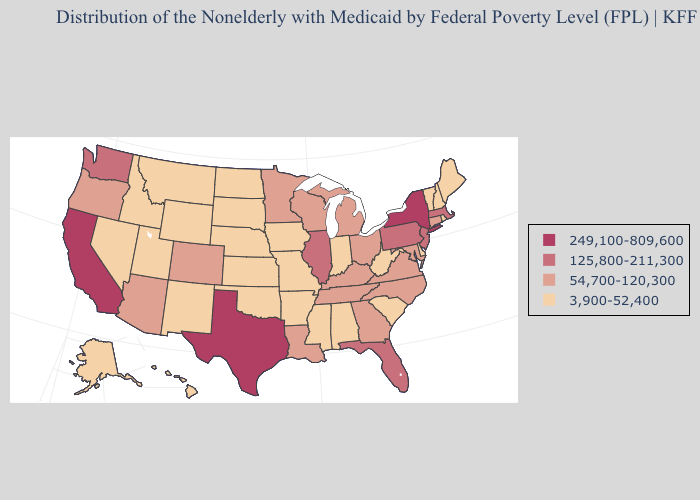Is the legend a continuous bar?
Write a very short answer. No. Name the states that have a value in the range 125,800-211,300?
Keep it brief. Florida, Illinois, Massachusetts, New Jersey, Pennsylvania, Washington. What is the value of South Dakota?
Quick response, please. 3,900-52,400. Does Kansas have a lower value than Nebraska?
Short answer required. No. What is the value of Massachusetts?
Write a very short answer. 125,800-211,300. What is the value of Washington?
Give a very brief answer. 125,800-211,300. What is the value of Utah?
Be succinct. 3,900-52,400. Among the states that border Ohio , which have the highest value?
Write a very short answer. Pennsylvania. Name the states that have a value in the range 125,800-211,300?
Give a very brief answer. Florida, Illinois, Massachusetts, New Jersey, Pennsylvania, Washington. Does the first symbol in the legend represent the smallest category?
Write a very short answer. No. Which states have the lowest value in the South?
Answer briefly. Alabama, Arkansas, Delaware, Mississippi, Oklahoma, South Carolina, West Virginia. Name the states that have a value in the range 125,800-211,300?
Give a very brief answer. Florida, Illinois, Massachusetts, New Jersey, Pennsylvania, Washington. What is the value of Iowa?
Give a very brief answer. 3,900-52,400. Which states hav the highest value in the Northeast?
Write a very short answer. New York. Does Maine have the same value as Washington?
Quick response, please. No. 